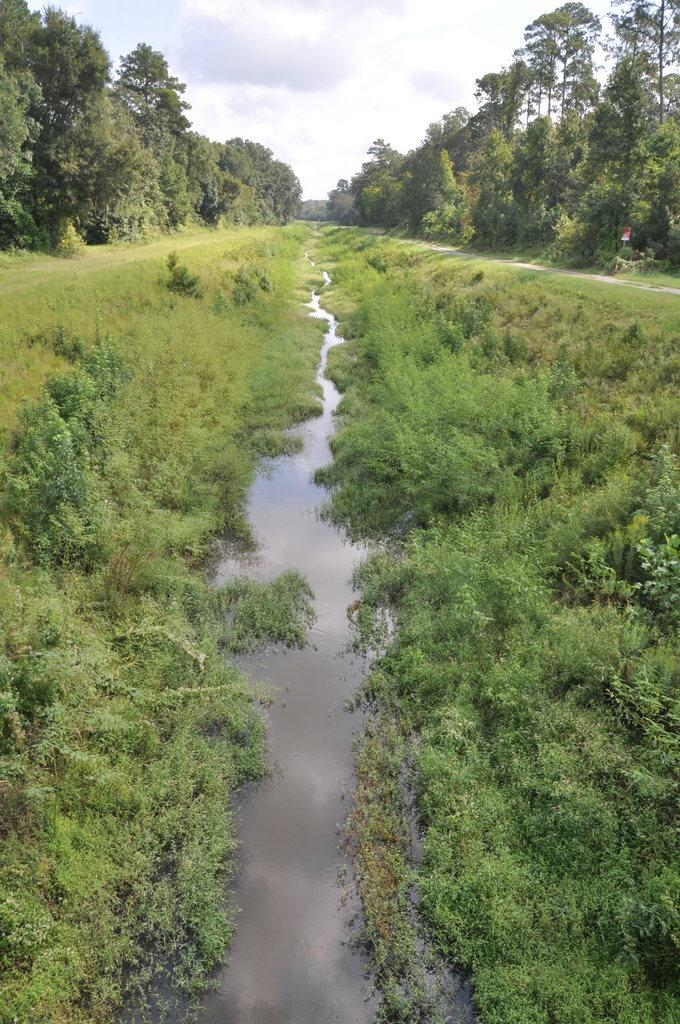What is the primary element visible in the image? There is water in the image. What type of vegetation can be seen in the image? There is grass in the image. What can be seen on the sides of the image? There are trees on either side of the image. Can you tell me how many ghosts are visible in the image? There are no ghosts present in the image. What type of education can be seen taking place in the image? There is no education or educational activity depicted in the image. 